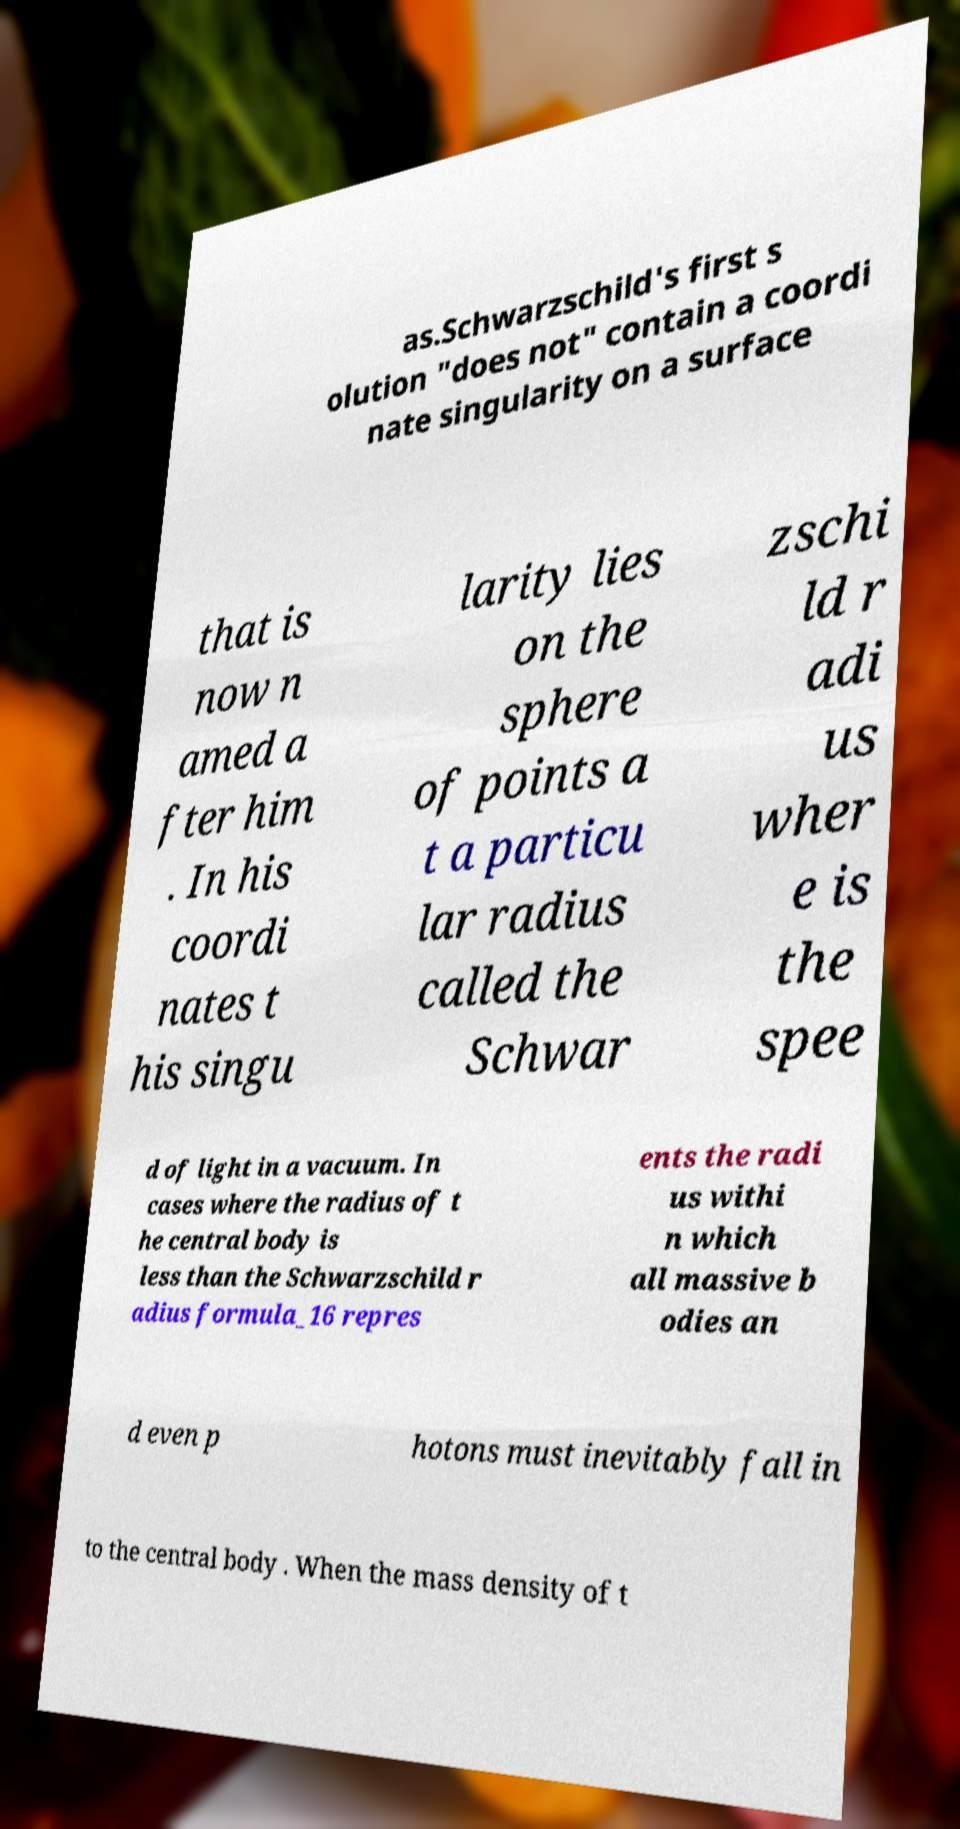Please read and relay the text visible in this image. What does it say? as.Schwarzschild's first s olution "does not" contain a coordi nate singularity on a surface that is now n amed a fter him . In his coordi nates t his singu larity lies on the sphere of points a t a particu lar radius called the Schwar zschi ld r adi us wher e is the spee d of light in a vacuum. In cases where the radius of t he central body is less than the Schwarzschild r adius formula_16 repres ents the radi us withi n which all massive b odies an d even p hotons must inevitably fall in to the central body . When the mass density of t 